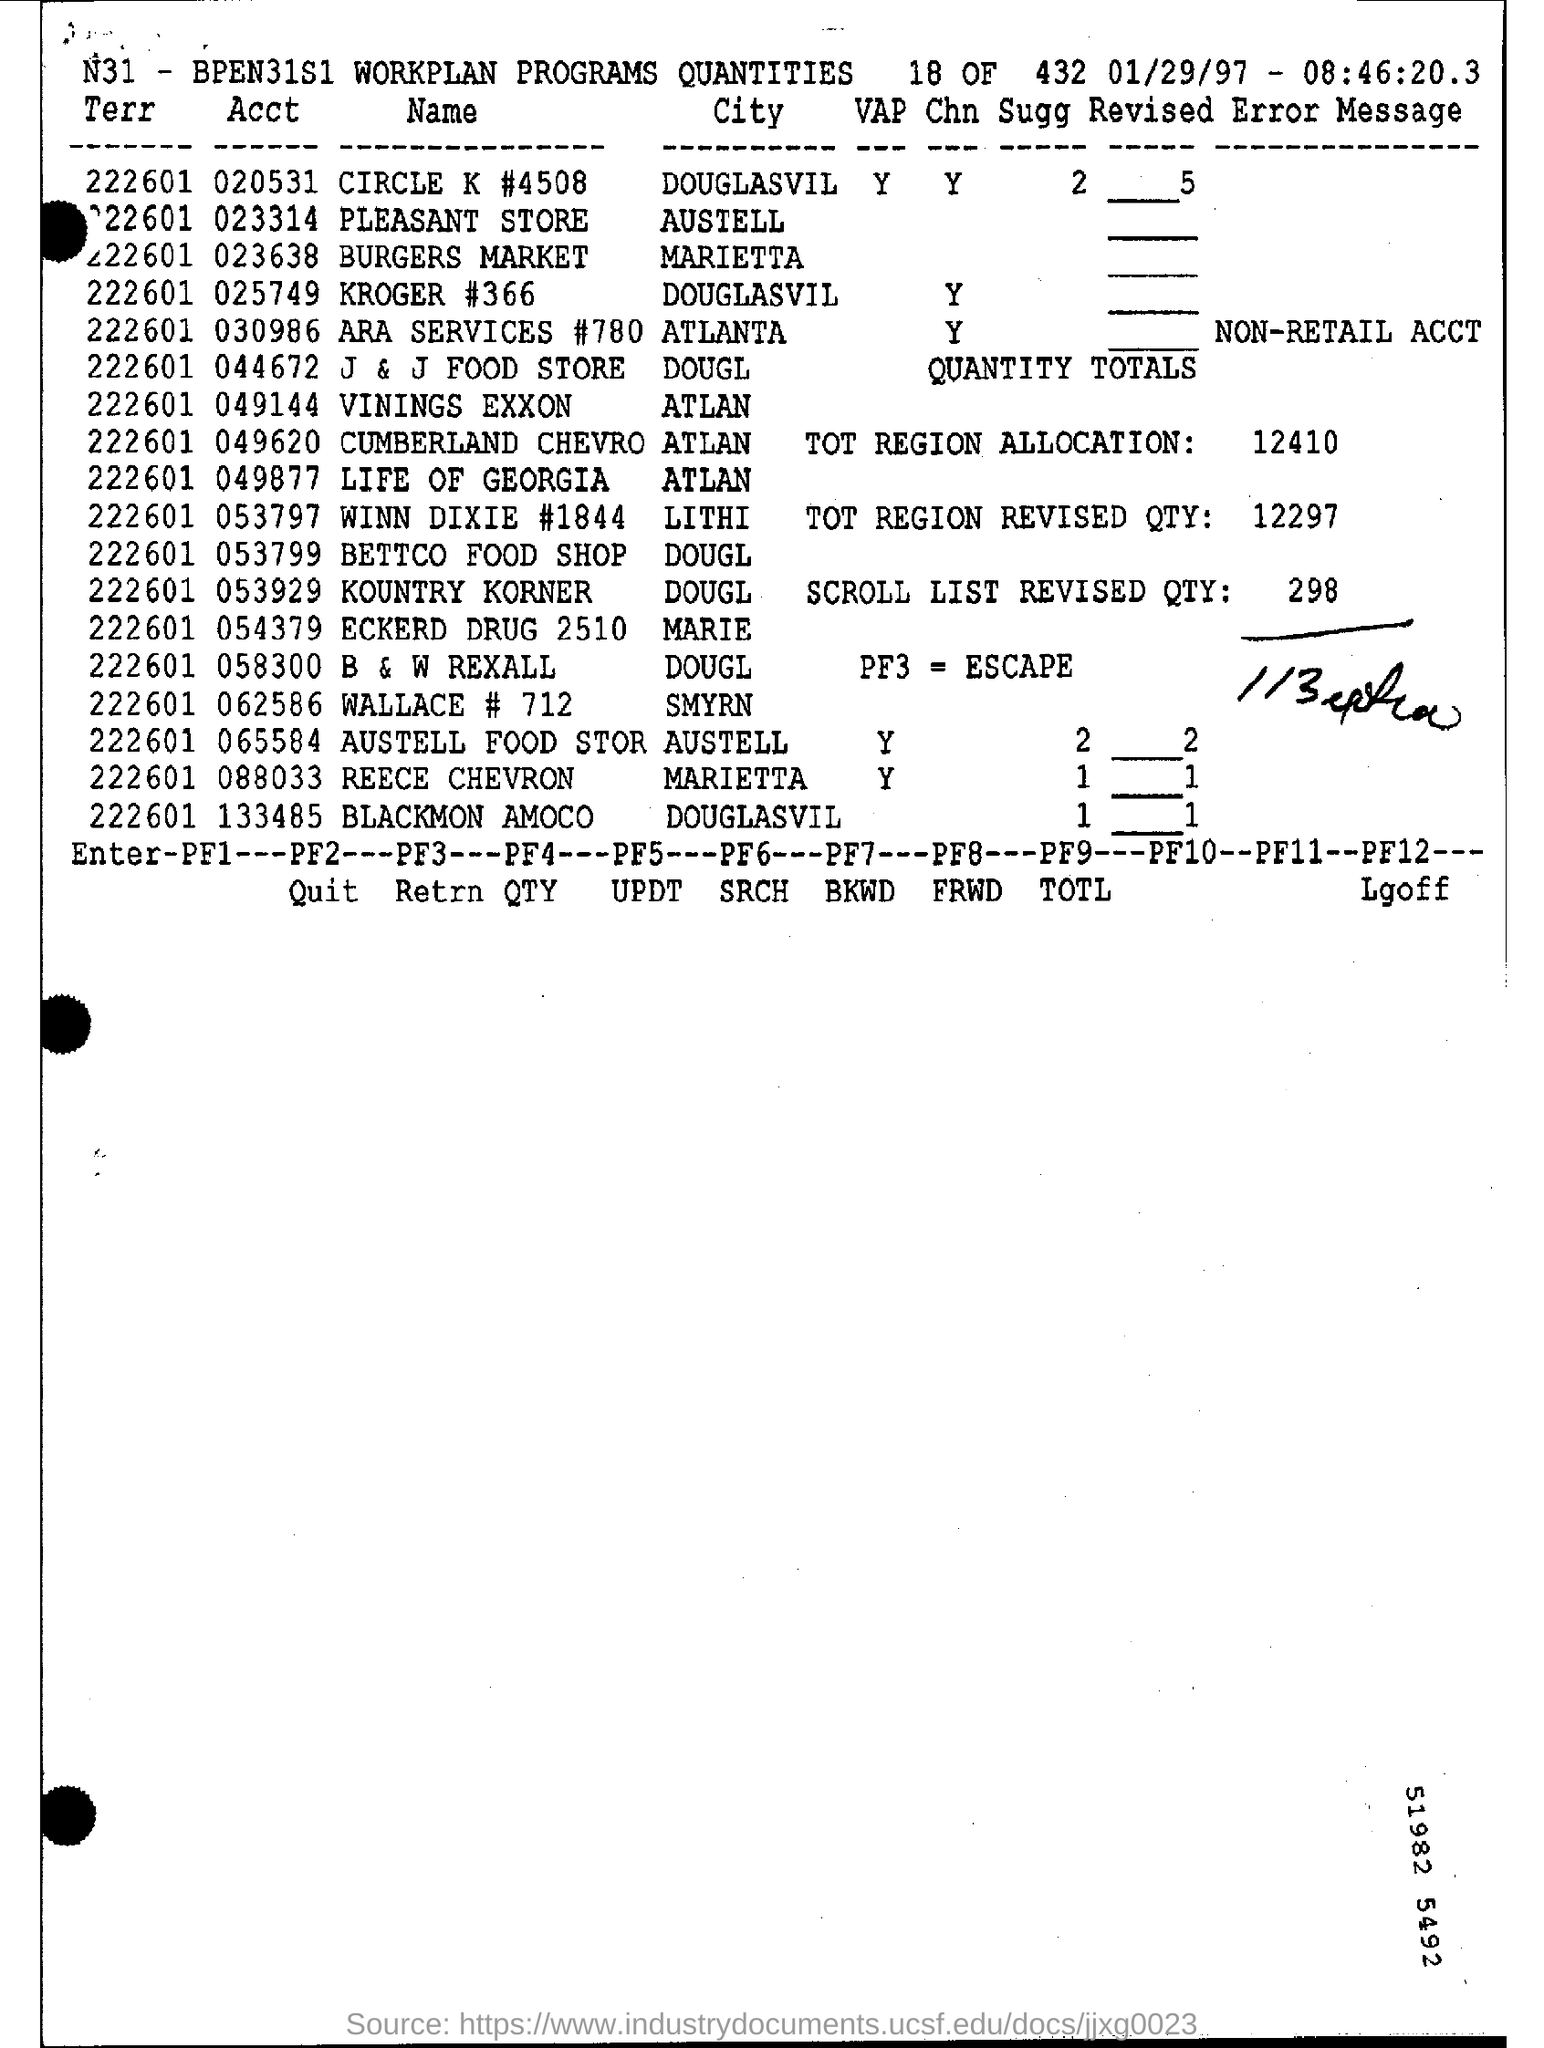Mention a couple of crucial points in this snapshot. Pleasant store is located in the city of Austell. The quantity of scroll lists revised is 298. PF3 is the escape key. The question "What is the total region allocation?" refers to the amount of a particular region that has been allocated or assigned to something or someone. The number "12410" is likely a specific example of a total region allocation, but more context is needed to provide a more complete answer. The account of Burgers Market is 023638. 